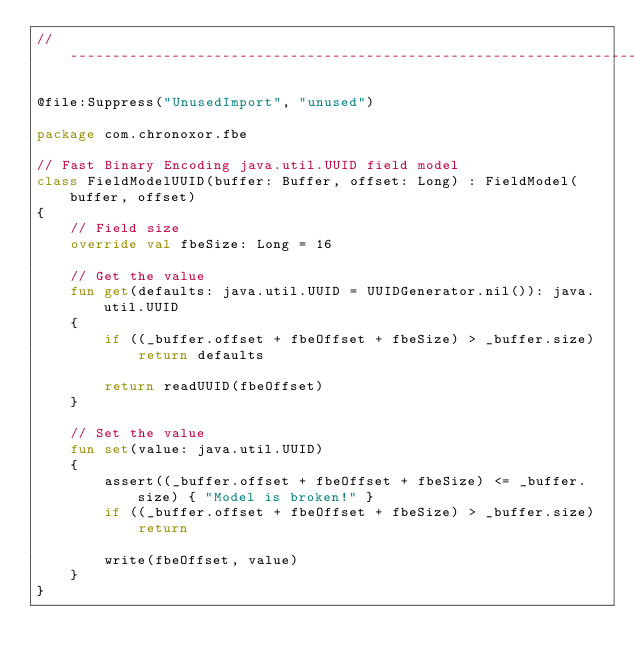<code> <loc_0><loc_0><loc_500><loc_500><_Kotlin_>//------------------------------------------------------------------------------

@file:Suppress("UnusedImport", "unused")

package com.chronoxor.fbe

// Fast Binary Encoding java.util.UUID field model
class FieldModelUUID(buffer: Buffer, offset: Long) : FieldModel(buffer, offset)
{
    // Field size
    override val fbeSize: Long = 16

    // Get the value
    fun get(defaults: java.util.UUID = UUIDGenerator.nil()): java.util.UUID
    {
        if ((_buffer.offset + fbeOffset + fbeSize) > _buffer.size)
            return defaults

        return readUUID(fbeOffset)
    }

    // Set the value
    fun set(value: java.util.UUID)
    {
        assert((_buffer.offset + fbeOffset + fbeSize) <= _buffer.size) { "Model is broken!" }
        if ((_buffer.offset + fbeOffset + fbeSize) > _buffer.size)
            return

        write(fbeOffset, value)
    }
}
</code> 